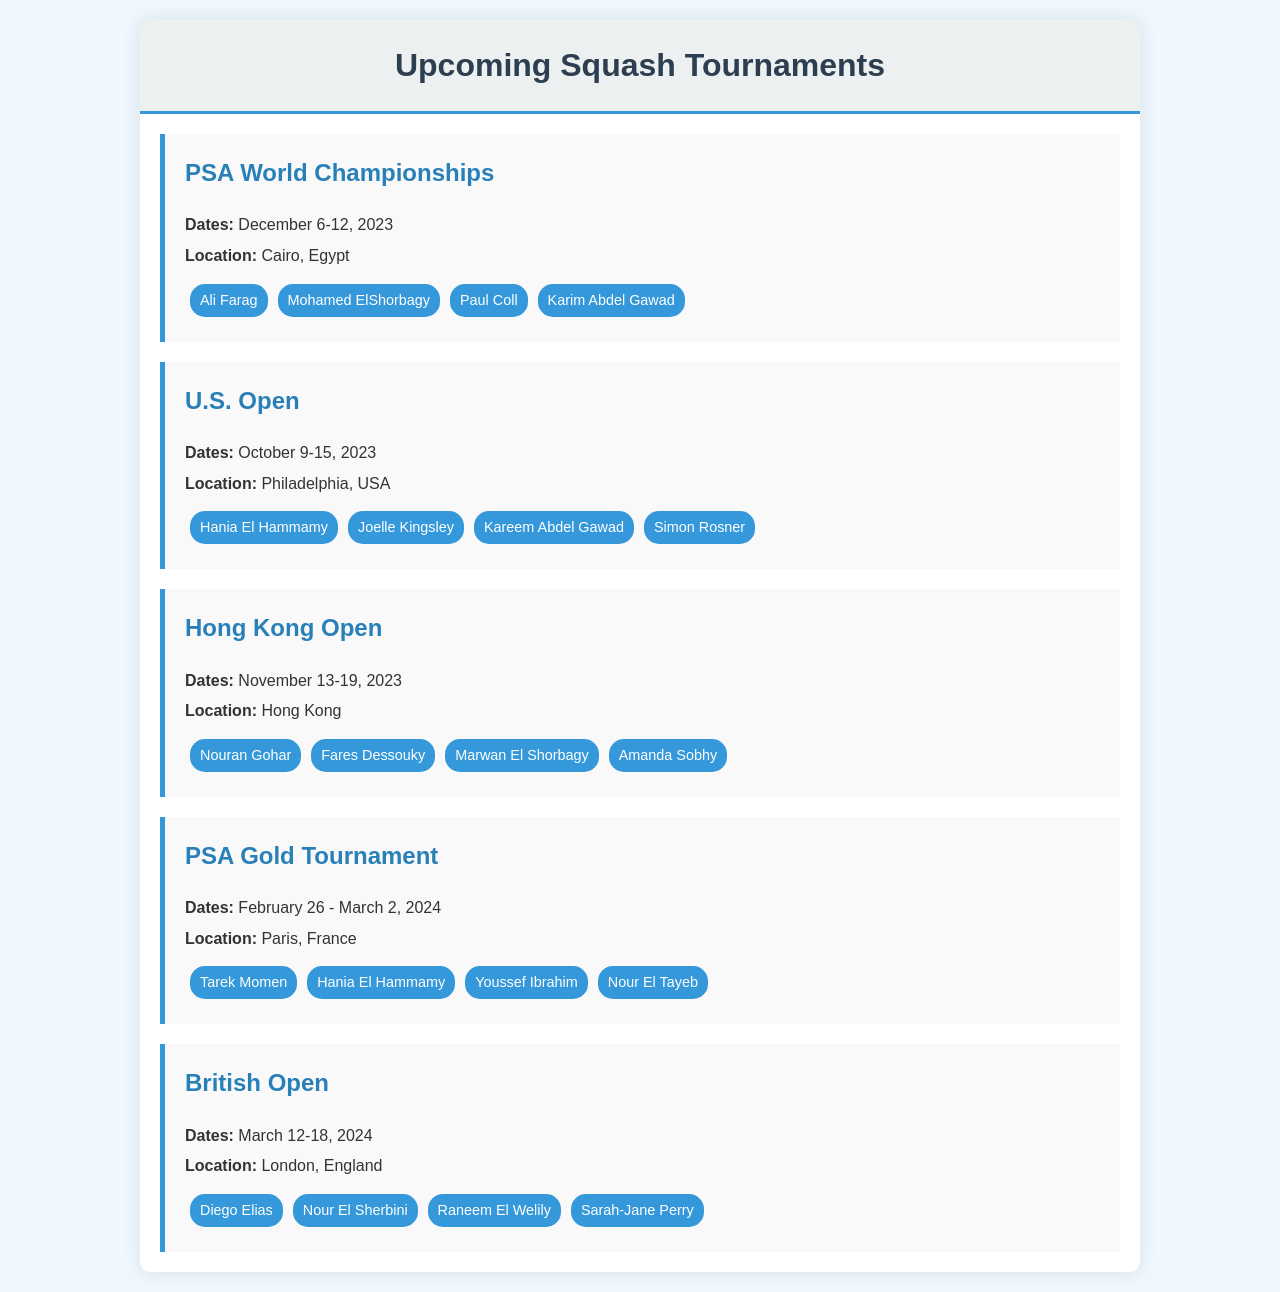What are the dates for the PSA World Championships? The PSA World Championships are scheduled from December 6 to December 12, 2023.
Answer: December 6-12, 2023 Where will the U.S. Open take place? The U.S. Open is set to be held in Philadelphia, USA.
Answer: Philadelphia, USA Who are the participants in the Hong Kong Open? The participants listed for the Hong Kong Open are Nouran Gohar, Fares Dessouky, Marwan El Shorbagy, and Amanda Sobhy.
Answer: Nouran Gohar, Fares Dessouky, Marwan El Shorbagy, Amanda Sobhy Which tournament occurs in March 2024? The tournaments scheduled in March 2024 are the PSA Gold Tournament and the British Open.
Answer: PSA Gold Tournament, British Open What is the location of the British Open? The British Open will be held in London, England.
Answer: London, England Which two players are also participating in the PSA Gold Tournament and U.S. Open? Hania El Hammamy and Karim Abdel Gawad are participating in both tournaments.
Answer: Hania El Hammamy, Karim Abdel Gawad How many tournaments are listed in the schedule? The document outlines five tournaments for the upcoming season.
Answer: Five What is the earliest tournament date mentioned? The earliest tournament date mentioned is October 9, 2023, for the U.S. Open.
Answer: October 9, 2023 